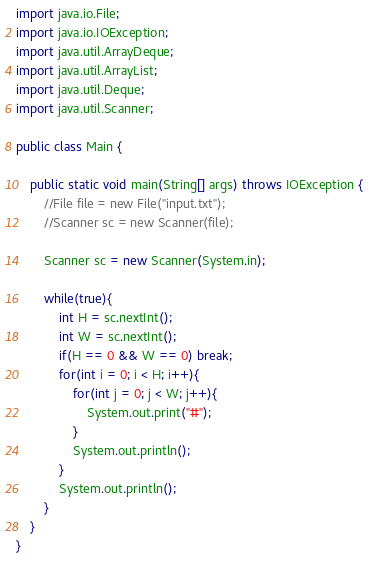<code> <loc_0><loc_0><loc_500><loc_500><_Java_>import java.io.File;
import java.io.IOException;
import java.util.ArrayDeque;
import java.util.ArrayList;
import java.util.Deque;
import java.util.Scanner;

public class Main {
 
	public static void main(String[] args) throws IOException {
		//File file = new File("input.txt");
		//Scanner sc = new Scanner(file);
		
		Scanner sc = new Scanner(System.in);
		
		while(true){
			int H = sc.nextInt();
			int W = sc.nextInt();
			if(H == 0 && W == 0) break;
			for(int i = 0; i < H; i++){
				for(int j = 0; j < W; j++){
					System.out.print("#");
				}
				System.out.println();
			}
			System.out.println();
		}
	}
}
</code> 